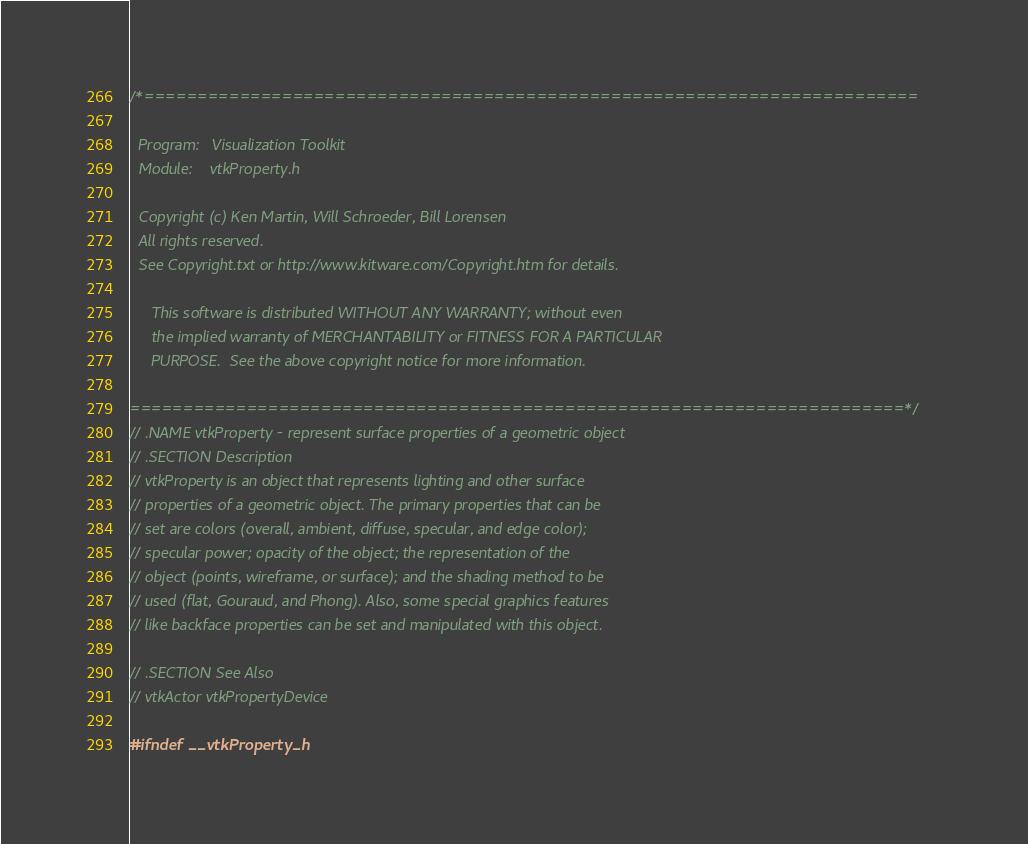Convert code to text. <code><loc_0><loc_0><loc_500><loc_500><_C_>/*=========================================================================

  Program:   Visualization Toolkit
  Module:    vtkProperty.h

  Copyright (c) Ken Martin, Will Schroeder, Bill Lorensen
  All rights reserved.
  See Copyright.txt or http://www.kitware.com/Copyright.htm for details.

     This software is distributed WITHOUT ANY WARRANTY; without even
     the implied warranty of MERCHANTABILITY or FITNESS FOR A PARTICULAR
     PURPOSE.  See the above copyright notice for more information.

=========================================================================*/
// .NAME vtkProperty - represent surface properties of a geometric object
// .SECTION Description
// vtkProperty is an object that represents lighting and other surface
// properties of a geometric object. The primary properties that can be 
// set are colors (overall, ambient, diffuse, specular, and edge color);
// specular power; opacity of the object; the representation of the
// object (points, wireframe, or surface); and the shading method to be 
// used (flat, Gouraud, and Phong). Also, some special graphics features
// like backface properties can be set and manipulated with this object.

// .SECTION See Also
// vtkActor vtkPropertyDevice

#ifndef __vtkProperty_h</code> 